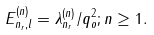<formula> <loc_0><loc_0><loc_500><loc_500>E _ { n _ { r } , l } ^ { ( n ) } = \lambda _ { n _ { r } } ^ { ( n ) } / q _ { o } ^ { 2 } ; n \geq 1 .</formula> 